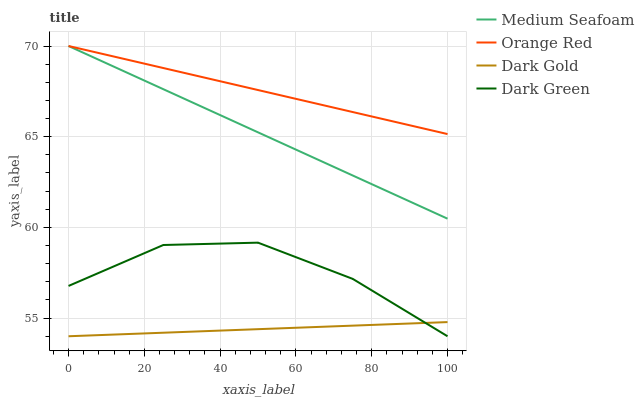Does Dark Gold have the minimum area under the curve?
Answer yes or no. Yes. Does Orange Red have the maximum area under the curve?
Answer yes or no. Yes. Does Medium Seafoam have the minimum area under the curve?
Answer yes or no. No. Does Medium Seafoam have the maximum area under the curve?
Answer yes or no. No. Is Dark Gold the smoothest?
Answer yes or no. Yes. Is Dark Green the roughest?
Answer yes or no. Yes. Is Medium Seafoam the smoothest?
Answer yes or no. No. Is Medium Seafoam the roughest?
Answer yes or no. No. Does Dark Green have the lowest value?
Answer yes or no. Yes. Does Medium Seafoam have the lowest value?
Answer yes or no. No. Does Orange Red have the highest value?
Answer yes or no. Yes. Does Dark Gold have the highest value?
Answer yes or no. No. Is Dark Green less than Medium Seafoam?
Answer yes or no. Yes. Is Orange Red greater than Dark Gold?
Answer yes or no. Yes. Does Dark Green intersect Dark Gold?
Answer yes or no. Yes. Is Dark Green less than Dark Gold?
Answer yes or no. No. Is Dark Green greater than Dark Gold?
Answer yes or no. No. Does Dark Green intersect Medium Seafoam?
Answer yes or no. No. 